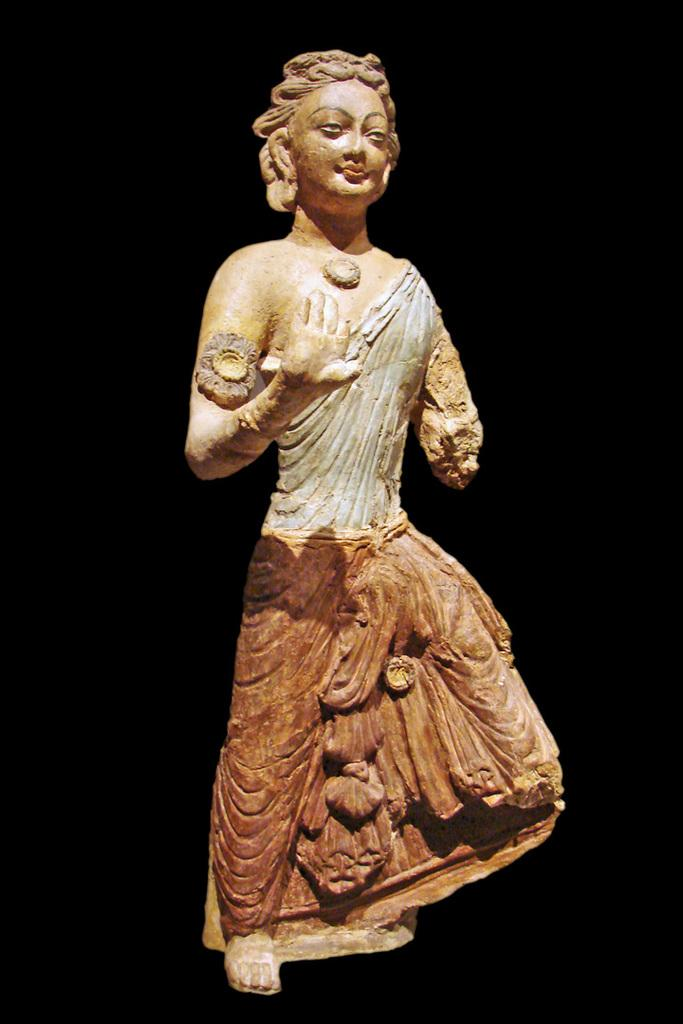What is the main subject of the image? There is a sculpture in the image. Can you describe the background of the sculpture? The background of the sculpture is dark. How does the army increase its efficiency in the image? There is no army present in the image; it features a sculpture with a dark background. 